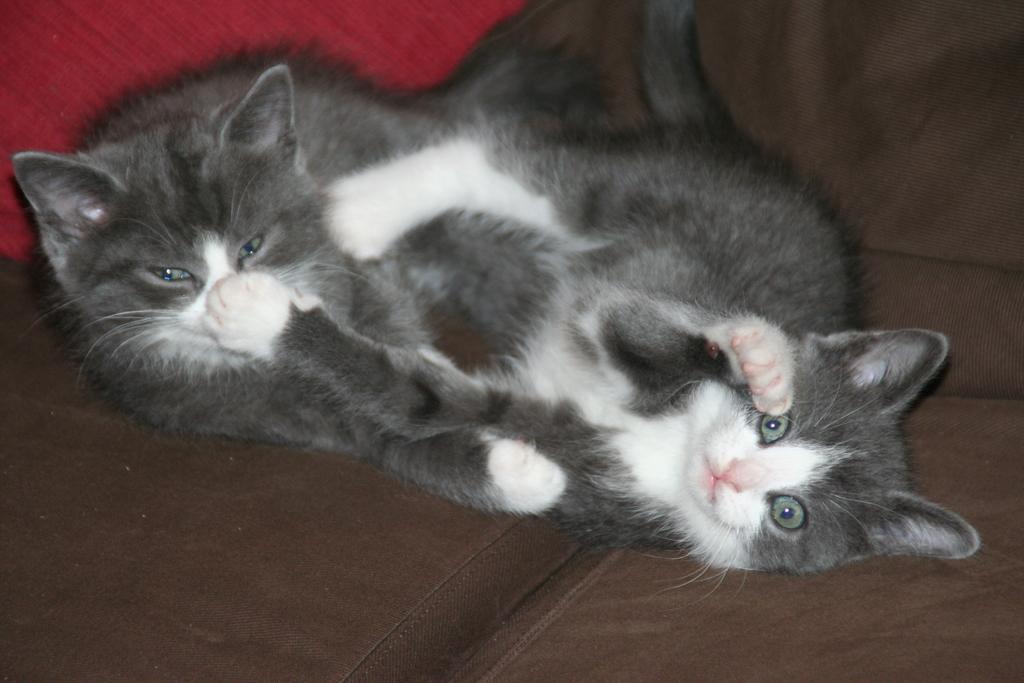Please provide a concise description of this image. In this image there are two cats laying on a sofa. 